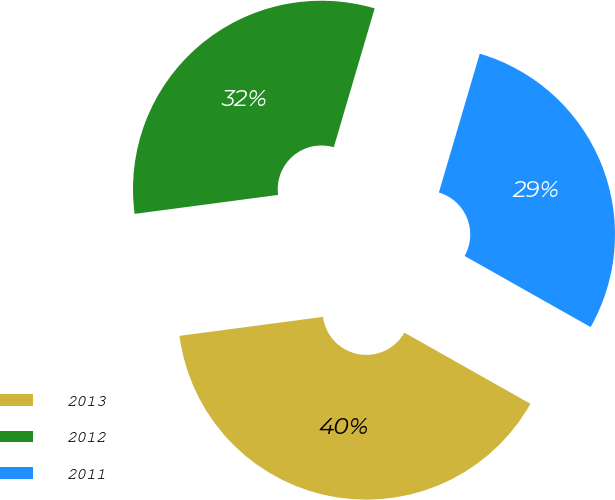<chart> <loc_0><loc_0><loc_500><loc_500><pie_chart><fcel>2013<fcel>2012<fcel>2011<nl><fcel>39.73%<fcel>31.65%<fcel>28.62%<nl></chart> 